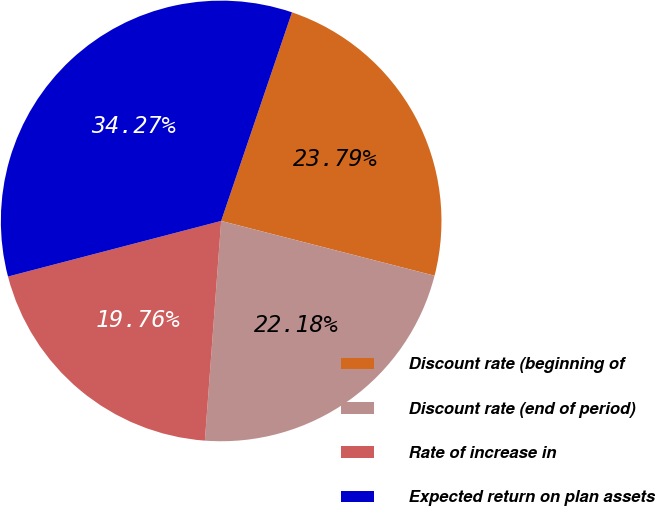<chart> <loc_0><loc_0><loc_500><loc_500><pie_chart><fcel>Discount rate (beginning of<fcel>Discount rate (end of period)<fcel>Rate of increase in<fcel>Expected return on plan assets<nl><fcel>23.79%<fcel>22.18%<fcel>19.76%<fcel>34.27%<nl></chart> 